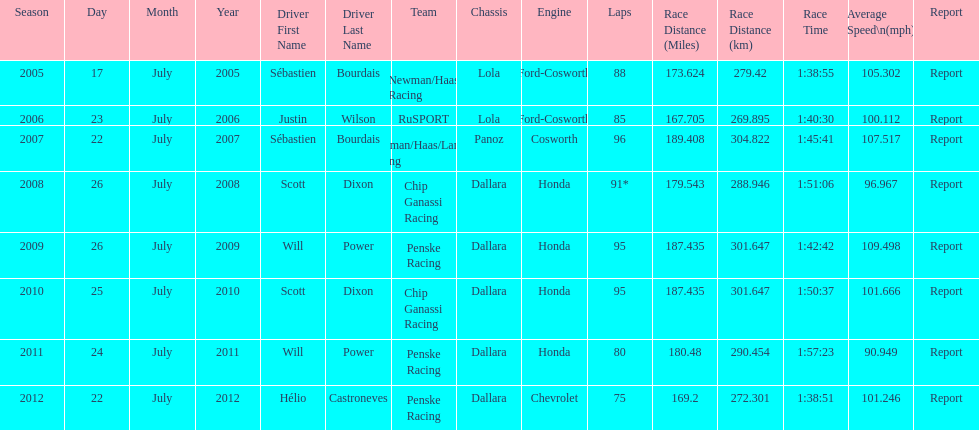What is the total number dallara chassis listed in the table? 5. 